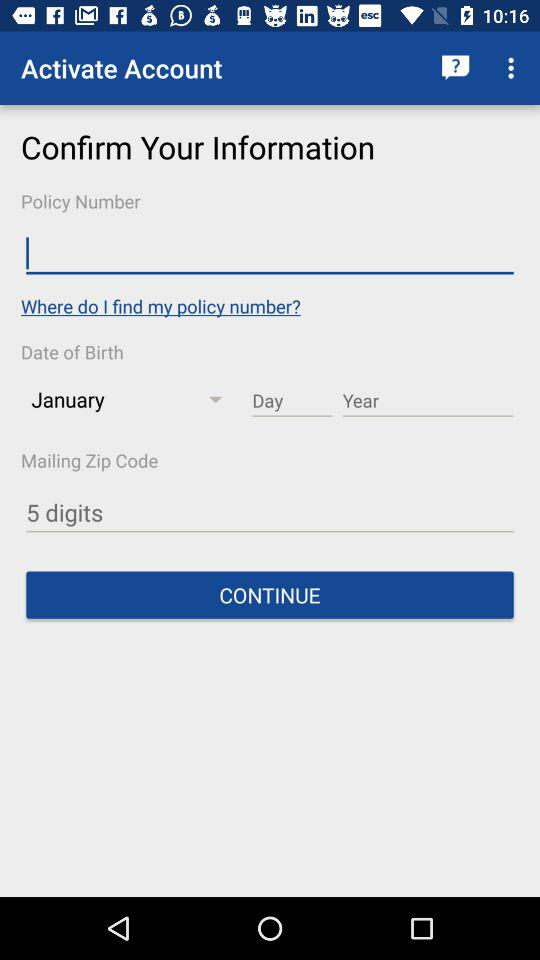How many digits are in the mailing zip code?
Answer the question using a single word or phrase. 5 